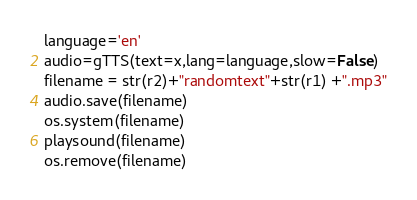Convert code to text. <code><loc_0><loc_0><loc_500><loc_500><_Python_>language='en'
audio=gTTS(text=x,lang=language,slow=False)
filename = str(r2)+"randomtext"+str(r1) +".mp3"
audio.save(filename)
os.system(filename)
playsound(filename)
os.remove(filename)</code> 